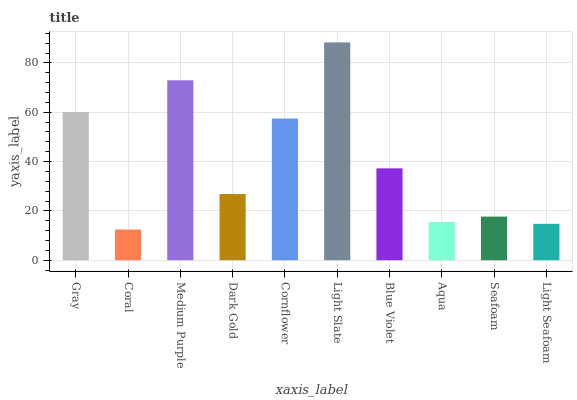Is Coral the minimum?
Answer yes or no. Yes. Is Light Slate the maximum?
Answer yes or no. Yes. Is Medium Purple the minimum?
Answer yes or no. No. Is Medium Purple the maximum?
Answer yes or no. No. Is Medium Purple greater than Coral?
Answer yes or no. Yes. Is Coral less than Medium Purple?
Answer yes or no. Yes. Is Coral greater than Medium Purple?
Answer yes or no. No. Is Medium Purple less than Coral?
Answer yes or no. No. Is Blue Violet the high median?
Answer yes or no. Yes. Is Dark Gold the low median?
Answer yes or no. Yes. Is Cornflower the high median?
Answer yes or no. No. Is Medium Purple the low median?
Answer yes or no. No. 